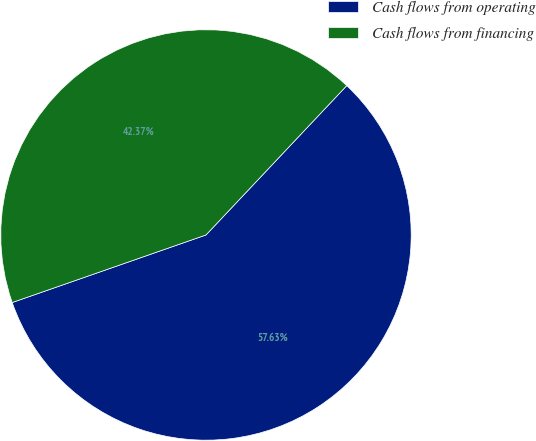Convert chart to OTSL. <chart><loc_0><loc_0><loc_500><loc_500><pie_chart><fcel>Cash flows from operating<fcel>Cash flows from financing<nl><fcel>57.63%<fcel>42.37%<nl></chart> 